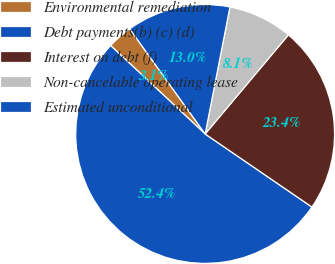<chart> <loc_0><loc_0><loc_500><loc_500><pie_chart><fcel>Environmental remediation<fcel>Debt payments(b) (c) (d)<fcel>Interest on debt (f)<fcel>Non-cancelable operating lease<fcel>Estimated unconditional<nl><fcel>3.12%<fcel>52.42%<fcel>23.43%<fcel>8.05%<fcel>12.98%<nl></chart> 